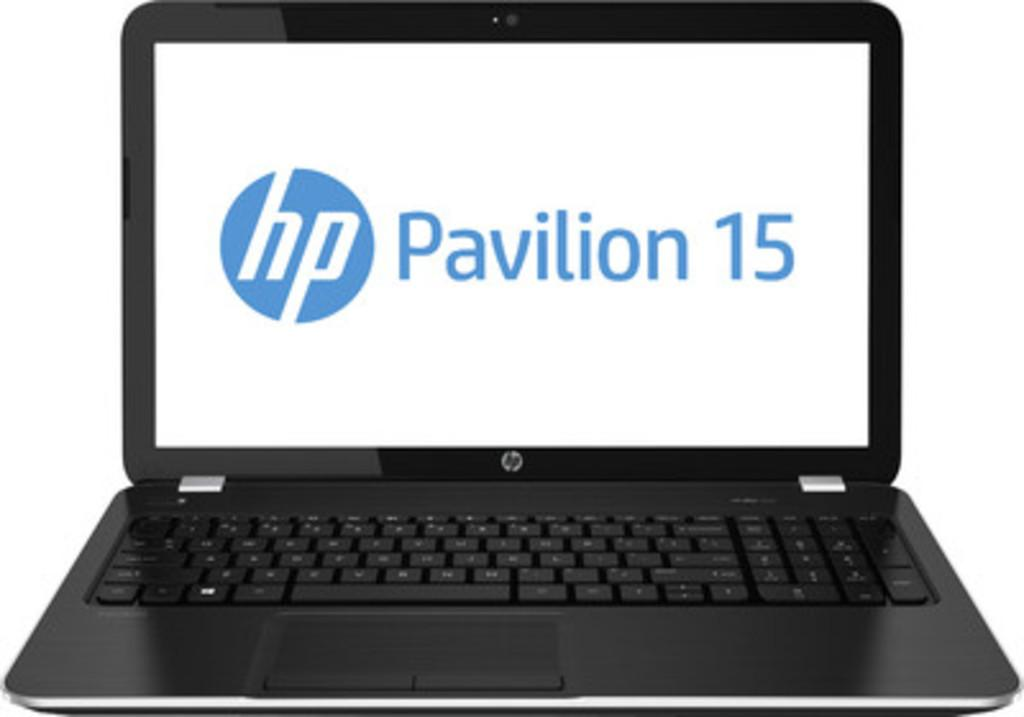<image>
Relay a brief, clear account of the picture shown. A laptop open with hp pavilion 15 on its screen. 